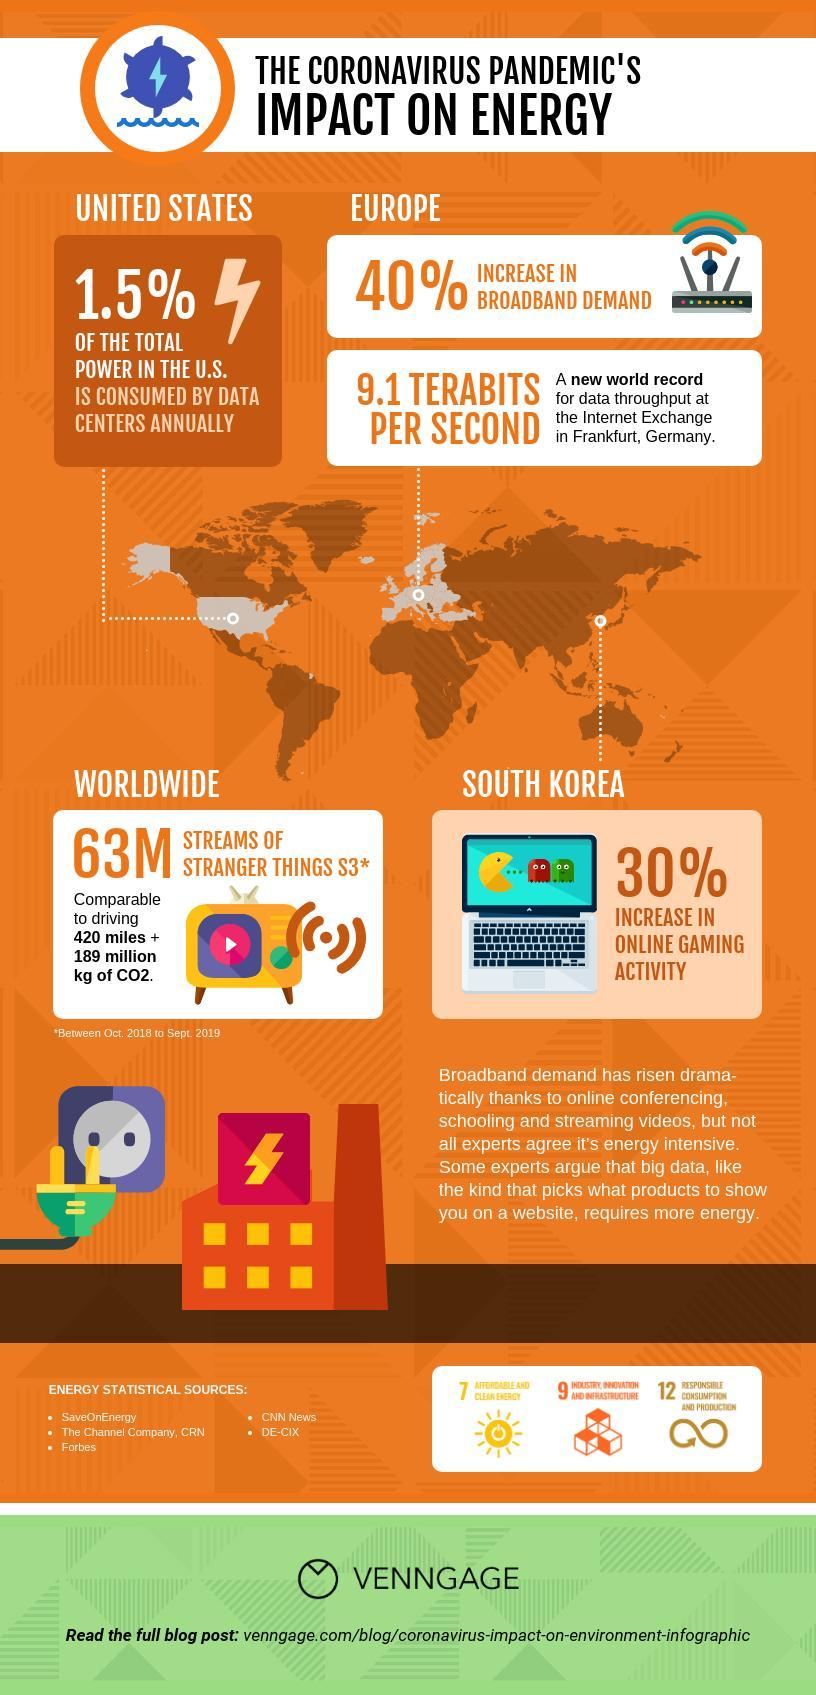How many energy statistical sources are given?
Answer the question with a short phrase. 5 